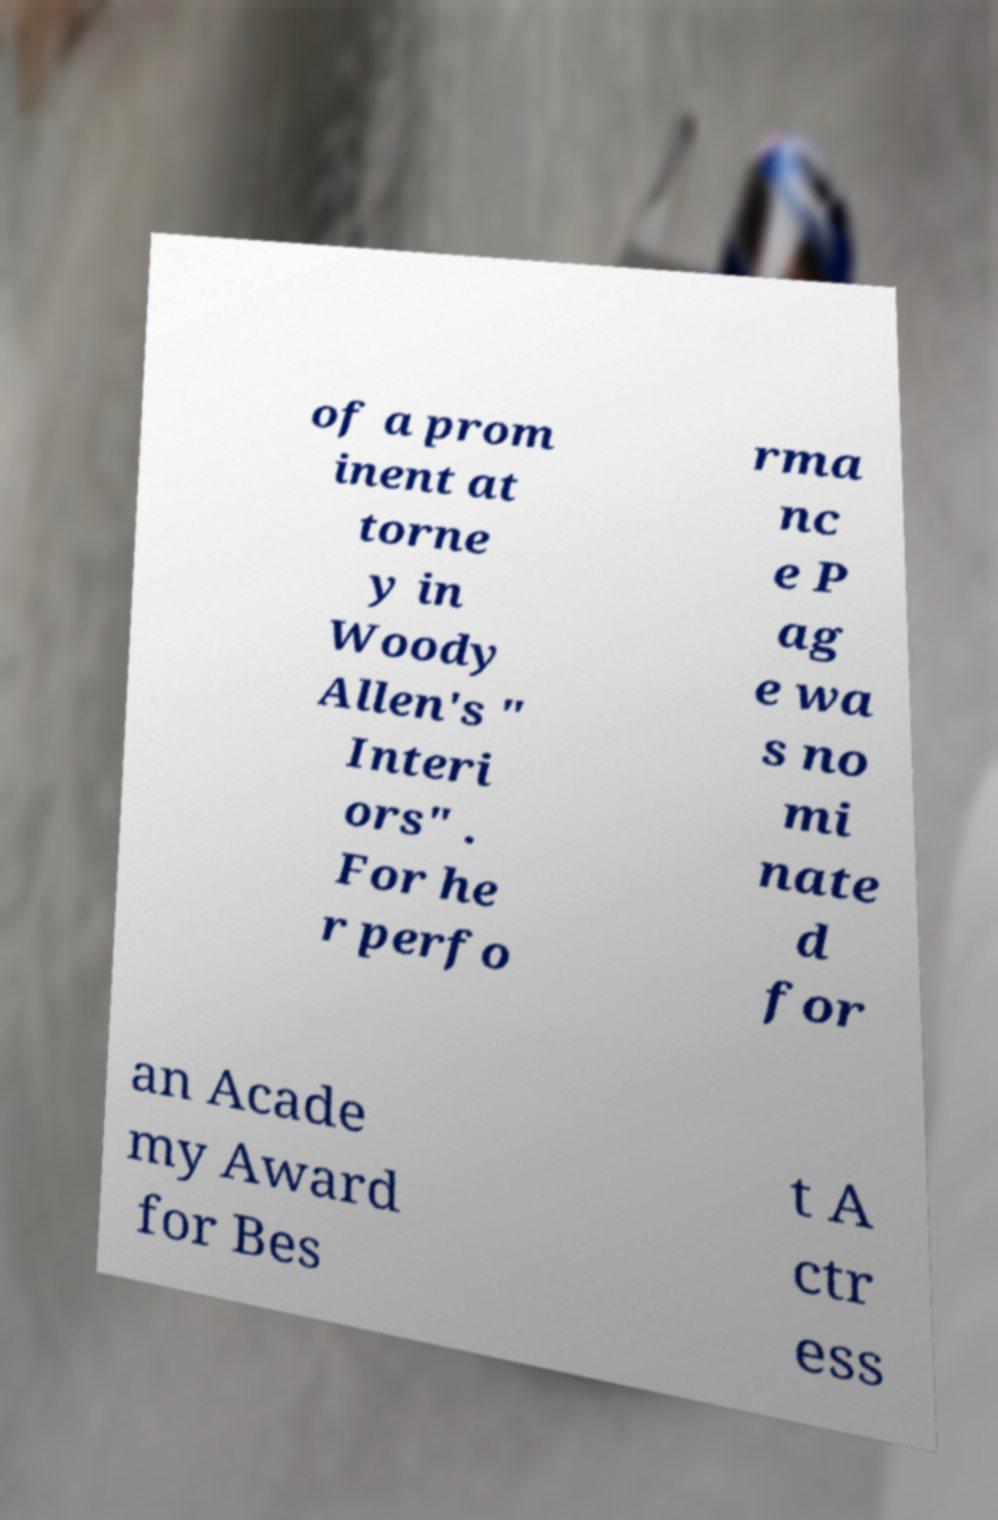Could you extract and type out the text from this image? of a prom inent at torne y in Woody Allen's " Interi ors" . For he r perfo rma nc e P ag e wa s no mi nate d for an Acade my Award for Bes t A ctr ess 